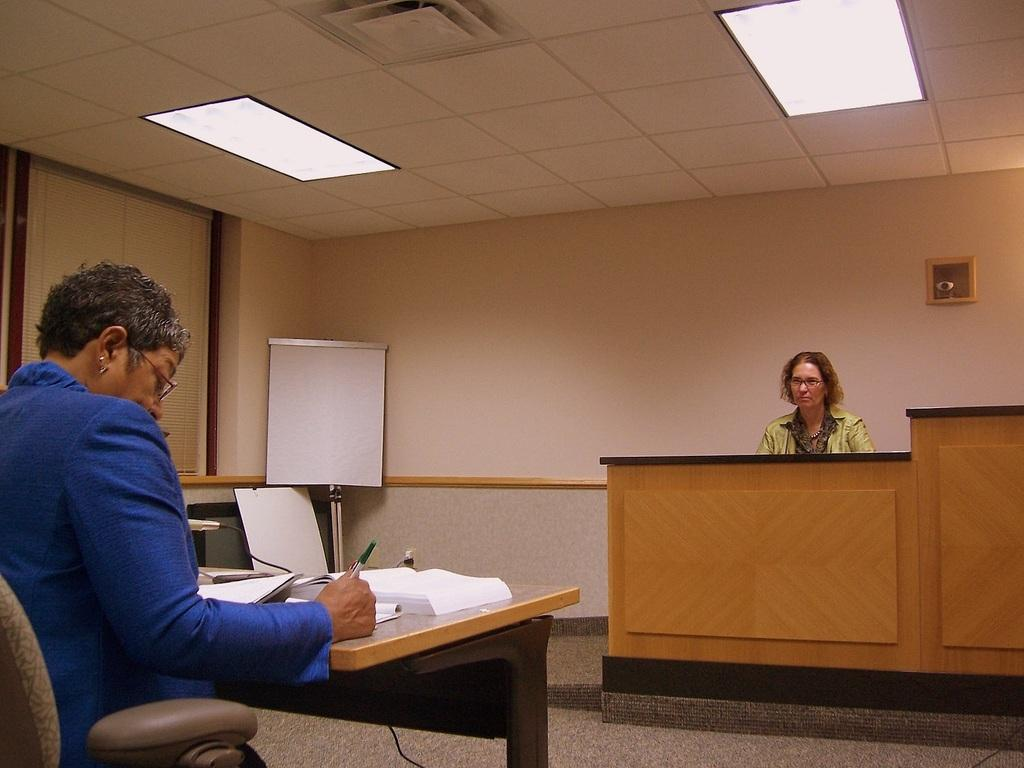What is the person in the image doing? There is a person sitting and writing in a book on a table. Can you describe the setting in the background? There is a woman sitting in the background, a board visible, and a wall in the background. What is the source of light in the image? There is a light at the top of the image. What type of rose can be seen growing on the wall in the image? There is no rose present in the image; the wall is visible in the background, but no plants or flowers are mentioned. 